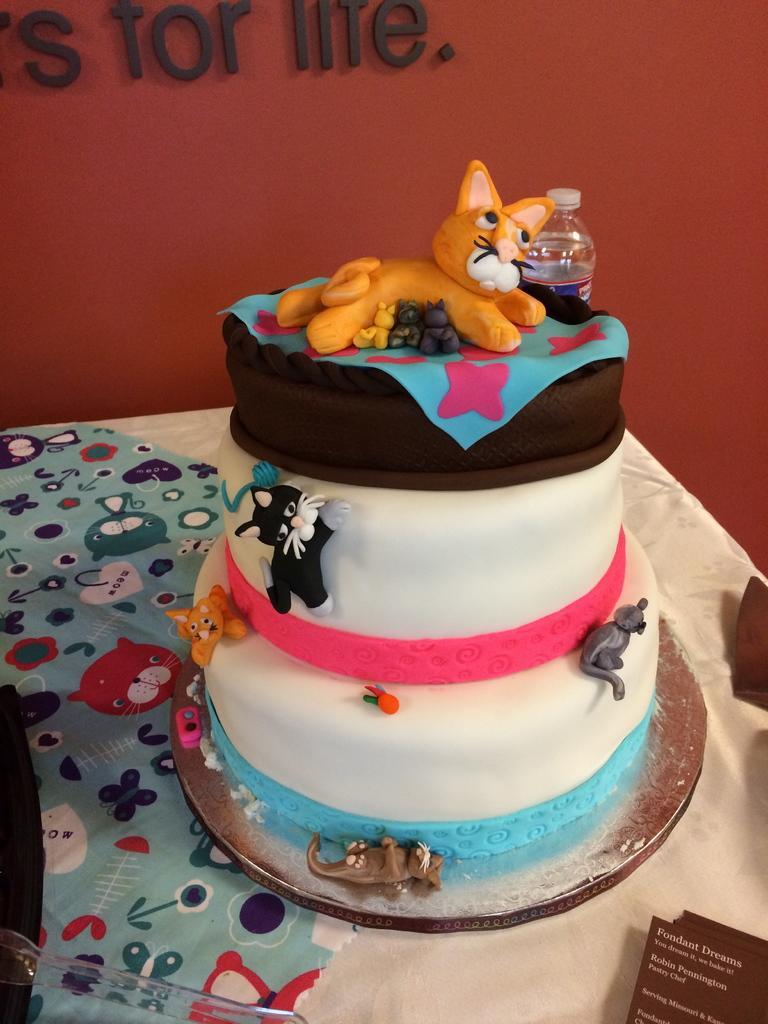Could you give a brief overview of what you see in this image? In the image we can see cake which is kept on the table. This is a wall, on the wall we can see for life. This is a bottle. 